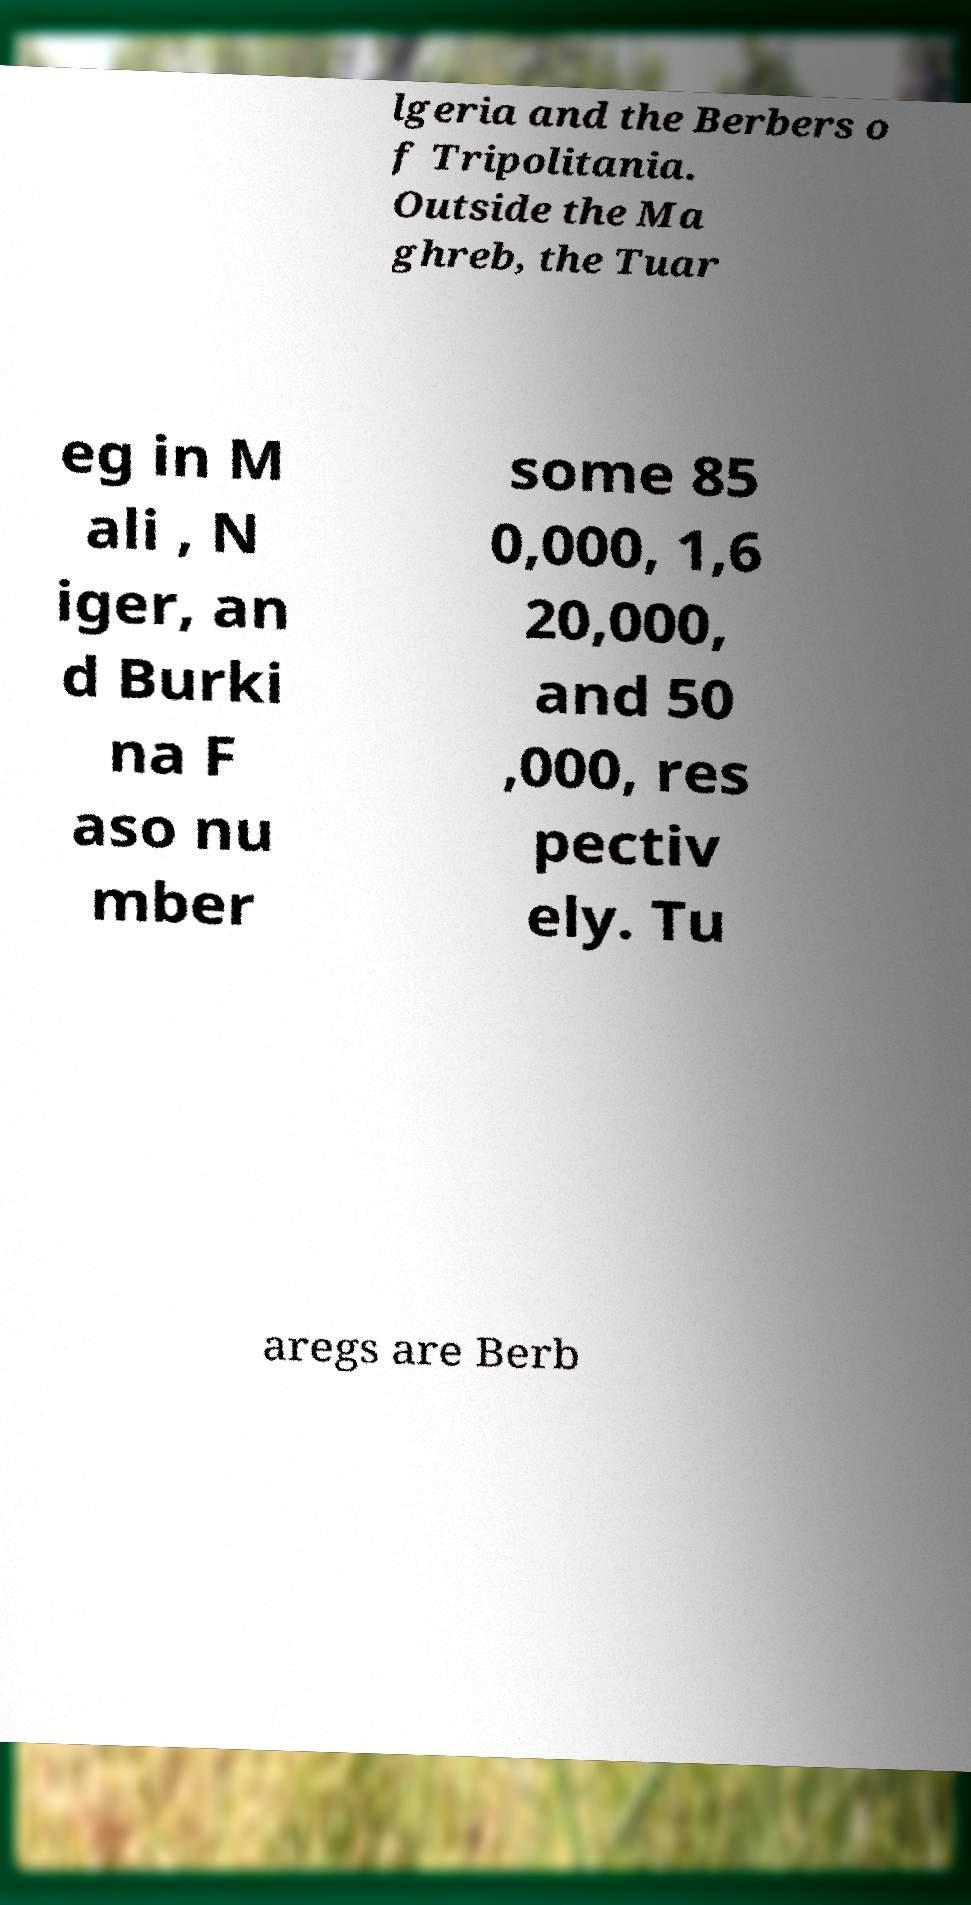Could you assist in decoding the text presented in this image and type it out clearly? lgeria and the Berbers o f Tripolitania. Outside the Ma ghreb, the Tuar eg in M ali , N iger, an d Burki na F aso nu mber some 85 0,000, 1,6 20,000, and 50 ,000, res pectiv ely. Tu aregs are Berb 